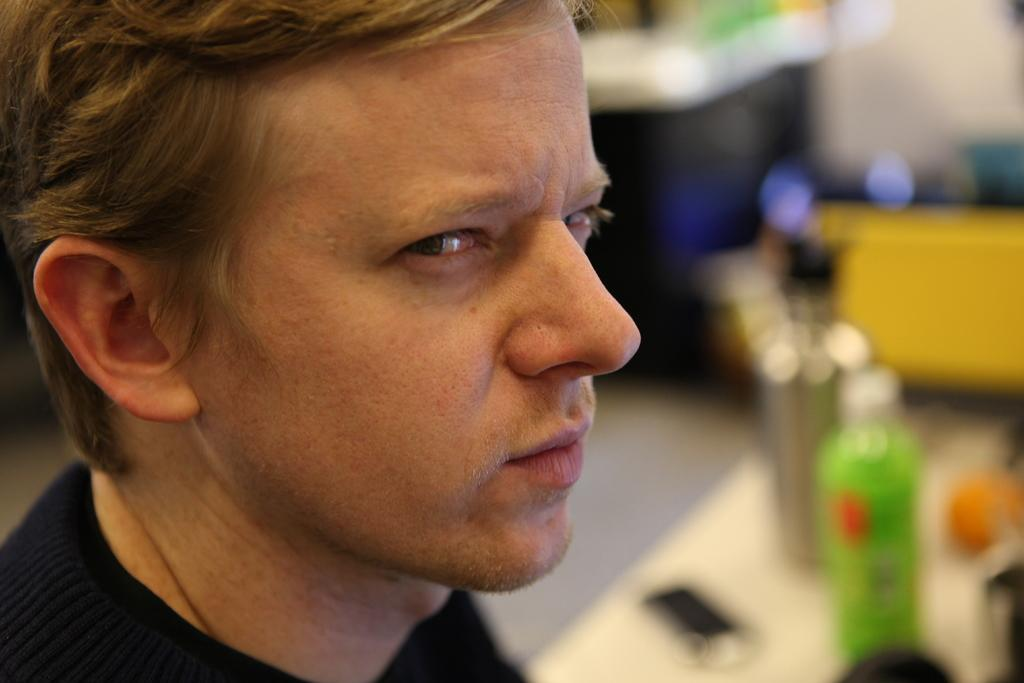What is the main subject of the image? There is a man in the image. What objects can be seen on the table in the image? There are bottles on the table in the image. Can you describe the background of the image? The background of the image is blurry. How does the man comfort the hook in the image? There is no hook present in the image, and therefore no such interaction can be observed. 